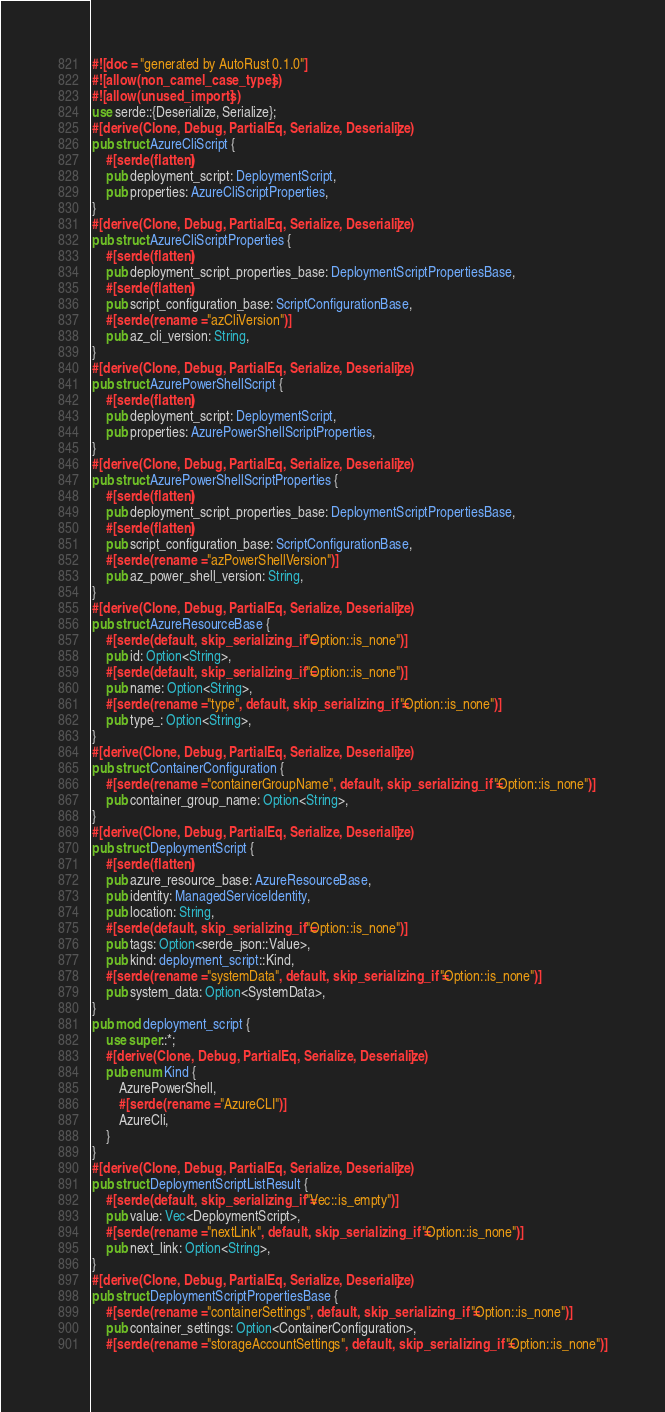<code> <loc_0><loc_0><loc_500><loc_500><_Rust_>#![doc = "generated by AutoRust 0.1.0"]
#![allow(non_camel_case_types)]
#![allow(unused_imports)]
use serde::{Deserialize, Serialize};
#[derive(Clone, Debug, PartialEq, Serialize, Deserialize)]
pub struct AzureCliScript {
    #[serde(flatten)]
    pub deployment_script: DeploymentScript,
    pub properties: AzureCliScriptProperties,
}
#[derive(Clone, Debug, PartialEq, Serialize, Deserialize)]
pub struct AzureCliScriptProperties {
    #[serde(flatten)]
    pub deployment_script_properties_base: DeploymentScriptPropertiesBase,
    #[serde(flatten)]
    pub script_configuration_base: ScriptConfigurationBase,
    #[serde(rename = "azCliVersion")]
    pub az_cli_version: String,
}
#[derive(Clone, Debug, PartialEq, Serialize, Deserialize)]
pub struct AzurePowerShellScript {
    #[serde(flatten)]
    pub deployment_script: DeploymentScript,
    pub properties: AzurePowerShellScriptProperties,
}
#[derive(Clone, Debug, PartialEq, Serialize, Deserialize)]
pub struct AzurePowerShellScriptProperties {
    #[serde(flatten)]
    pub deployment_script_properties_base: DeploymentScriptPropertiesBase,
    #[serde(flatten)]
    pub script_configuration_base: ScriptConfigurationBase,
    #[serde(rename = "azPowerShellVersion")]
    pub az_power_shell_version: String,
}
#[derive(Clone, Debug, PartialEq, Serialize, Deserialize)]
pub struct AzureResourceBase {
    #[serde(default, skip_serializing_if = "Option::is_none")]
    pub id: Option<String>,
    #[serde(default, skip_serializing_if = "Option::is_none")]
    pub name: Option<String>,
    #[serde(rename = "type", default, skip_serializing_if = "Option::is_none")]
    pub type_: Option<String>,
}
#[derive(Clone, Debug, PartialEq, Serialize, Deserialize)]
pub struct ContainerConfiguration {
    #[serde(rename = "containerGroupName", default, skip_serializing_if = "Option::is_none")]
    pub container_group_name: Option<String>,
}
#[derive(Clone, Debug, PartialEq, Serialize, Deserialize)]
pub struct DeploymentScript {
    #[serde(flatten)]
    pub azure_resource_base: AzureResourceBase,
    pub identity: ManagedServiceIdentity,
    pub location: String,
    #[serde(default, skip_serializing_if = "Option::is_none")]
    pub tags: Option<serde_json::Value>,
    pub kind: deployment_script::Kind,
    #[serde(rename = "systemData", default, skip_serializing_if = "Option::is_none")]
    pub system_data: Option<SystemData>,
}
pub mod deployment_script {
    use super::*;
    #[derive(Clone, Debug, PartialEq, Serialize, Deserialize)]
    pub enum Kind {
        AzurePowerShell,
        #[serde(rename = "AzureCLI")]
        AzureCli,
    }
}
#[derive(Clone, Debug, PartialEq, Serialize, Deserialize)]
pub struct DeploymentScriptListResult {
    #[serde(default, skip_serializing_if = "Vec::is_empty")]
    pub value: Vec<DeploymentScript>,
    #[serde(rename = "nextLink", default, skip_serializing_if = "Option::is_none")]
    pub next_link: Option<String>,
}
#[derive(Clone, Debug, PartialEq, Serialize, Deserialize)]
pub struct DeploymentScriptPropertiesBase {
    #[serde(rename = "containerSettings", default, skip_serializing_if = "Option::is_none")]
    pub container_settings: Option<ContainerConfiguration>,
    #[serde(rename = "storageAccountSettings", default, skip_serializing_if = "Option::is_none")]</code> 